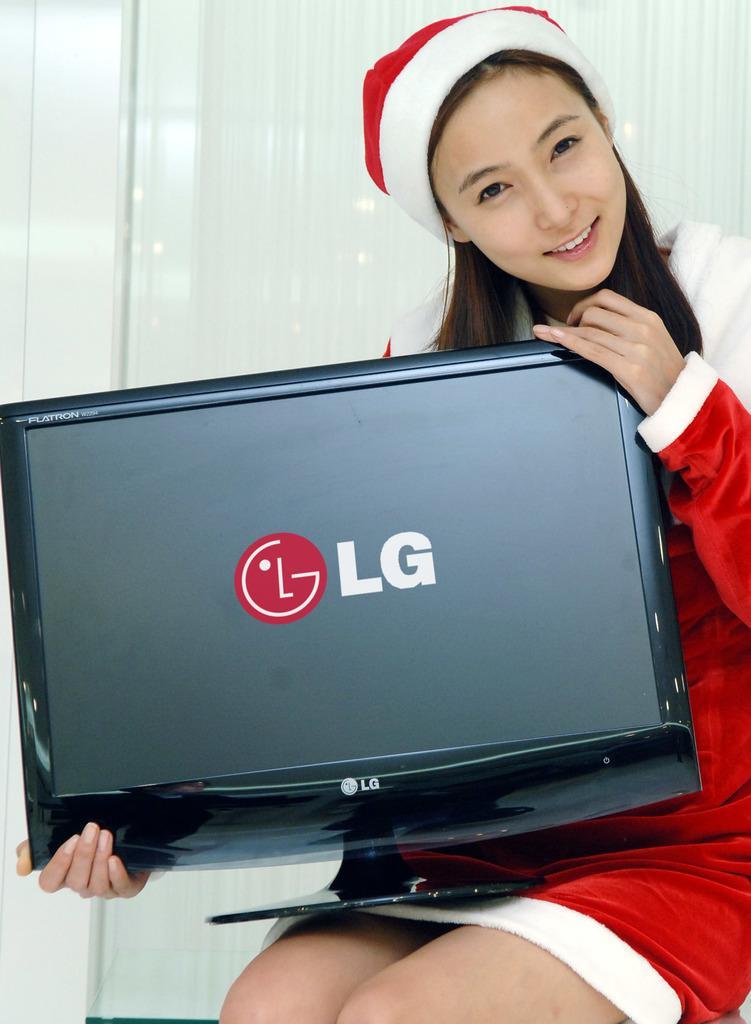How would you summarize this image in a sentence or two? In this picture I can see there is a woman sitting and she is wearing a red and white dress and a cap. She is smiling and holding a television and there is a logo displayed on the screen and there is a logo and there is a glass window in the backdrop with a curtain. 